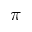Convert formula to latex. <formula><loc_0><loc_0><loc_500><loc_500>\pi</formula> 